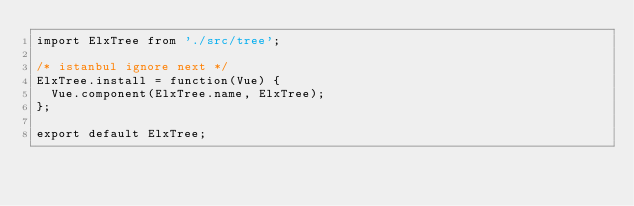<code> <loc_0><loc_0><loc_500><loc_500><_JavaScript_>import ElxTree from './src/tree';

/* istanbul ignore next */
ElxTree.install = function(Vue) {
  Vue.component(ElxTree.name, ElxTree);
};

export default ElxTree;
</code> 